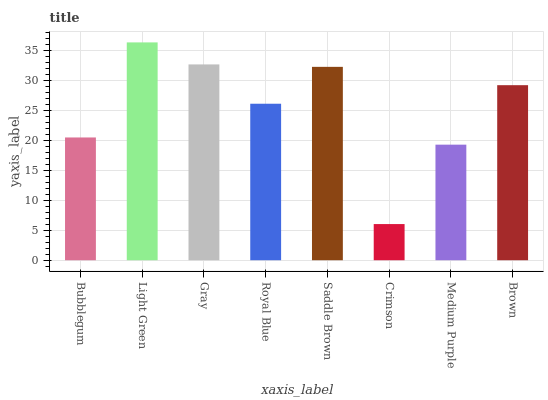Is Gray the minimum?
Answer yes or no. No. Is Gray the maximum?
Answer yes or no. No. Is Light Green greater than Gray?
Answer yes or no. Yes. Is Gray less than Light Green?
Answer yes or no. Yes. Is Gray greater than Light Green?
Answer yes or no. No. Is Light Green less than Gray?
Answer yes or no. No. Is Brown the high median?
Answer yes or no. Yes. Is Royal Blue the low median?
Answer yes or no. Yes. Is Saddle Brown the high median?
Answer yes or no. No. Is Crimson the low median?
Answer yes or no. No. 